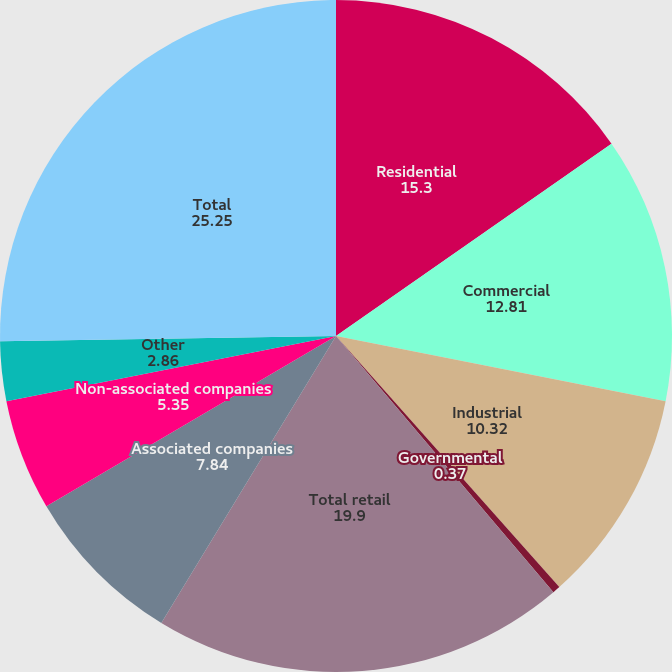Convert chart to OTSL. <chart><loc_0><loc_0><loc_500><loc_500><pie_chart><fcel>Residential<fcel>Commercial<fcel>Industrial<fcel>Governmental<fcel>Total retail<fcel>Associated companies<fcel>Non-associated companies<fcel>Other<fcel>Total<nl><fcel>15.3%<fcel>12.81%<fcel>10.32%<fcel>0.37%<fcel>19.9%<fcel>7.84%<fcel>5.35%<fcel>2.86%<fcel>25.25%<nl></chart> 